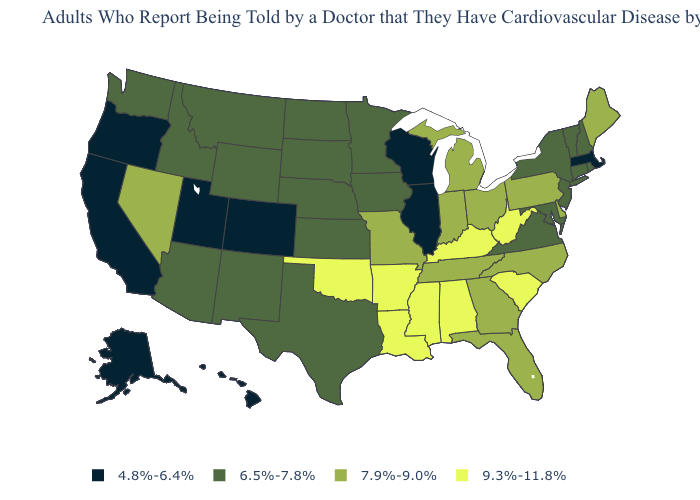Name the states that have a value in the range 7.9%-9.0%?
Short answer required. Delaware, Florida, Georgia, Indiana, Maine, Michigan, Missouri, Nevada, North Carolina, Ohio, Pennsylvania, Tennessee. Does the first symbol in the legend represent the smallest category?
Short answer required. Yes. Which states have the lowest value in the USA?
Be succinct. Alaska, California, Colorado, Hawaii, Illinois, Massachusetts, Oregon, Utah, Wisconsin. Name the states that have a value in the range 6.5%-7.8%?
Keep it brief. Arizona, Connecticut, Idaho, Iowa, Kansas, Maryland, Minnesota, Montana, Nebraska, New Hampshire, New Jersey, New Mexico, New York, North Dakota, Rhode Island, South Dakota, Texas, Vermont, Virginia, Washington, Wyoming. Name the states that have a value in the range 4.8%-6.4%?
Be succinct. Alaska, California, Colorado, Hawaii, Illinois, Massachusetts, Oregon, Utah, Wisconsin. Does the map have missing data?
Be succinct. No. Among the states that border Colorado , does Utah have the highest value?
Answer briefly. No. Does the map have missing data?
Keep it brief. No. Among the states that border Pennsylvania , which have the lowest value?
Keep it brief. Maryland, New Jersey, New York. Which states have the lowest value in the USA?
Quick response, please. Alaska, California, Colorado, Hawaii, Illinois, Massachusetts, Oregon, Utah, Wisconsin. What is the value of Oregon?
Keep it brief. 4.8%-6.4%. Does Illinois have the lowest value in the USA?
Write a very short answer. Yes. What is the lowest value in the Northeast?
Be succinct. 4.8%-6.4%. What is the highest value in states that border Wisconsin?
Answer briefly. 7.9%-9.0%. Among the states that border Tennessee , which have the highest value?
Give a very brief answer. Alabama, Arkansas, Kentucky, Mississippi. 